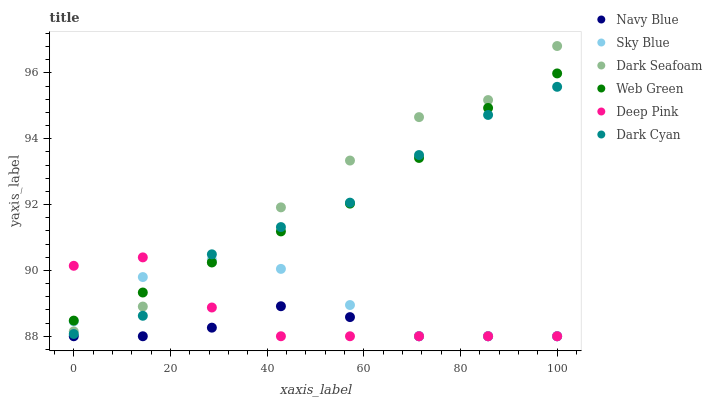Does Navy Blue have the minimum area under the curve?
Answer yes or no. Yes. Does Dark Seafoam have the maximum area under the curve?
Answer yes or no. Yes. Does Web Green have the minimum area under the curve?
Answer yes or no. No. Does Web Green have the maximum area under the curve?
Answer yes or no. No. Is Web Green the smoothest?
Answer yes or no. Yes. Is Dark Cyan the roughest?
Answer yes or no. Yes. Is Navy Blue the smoothest?
Answer yes or no. No. Is Navy Blue the roughest?
Answer yes or no. No. Does Deep Pink have the lowest value?
Answer yes or no. Yes. Does Web Green have the lowest value?
Answer yes or no. No. Does Dark Seafoam have the highest value?
Answer yes or no. Yes. Does Web Green have the highest value?
Answer yes or no. No. Is Navy Blue less than Dark Seafoam?
Answer yes or no. Yes. Is Dark Cyan greater than Navy Blue?
Answer yes or no. Yes. Does Web Green intersect Dark Seafoam?
Answer yes or no. Yes. Is Web Green less than Dark Seafoam?
Answer yes or no. No. Is Web Green greater than Dark Seafoam?
Answer yes or no. No. Does Navy Blue intersect Dark Seafoam?
Answer yes or no. No. 